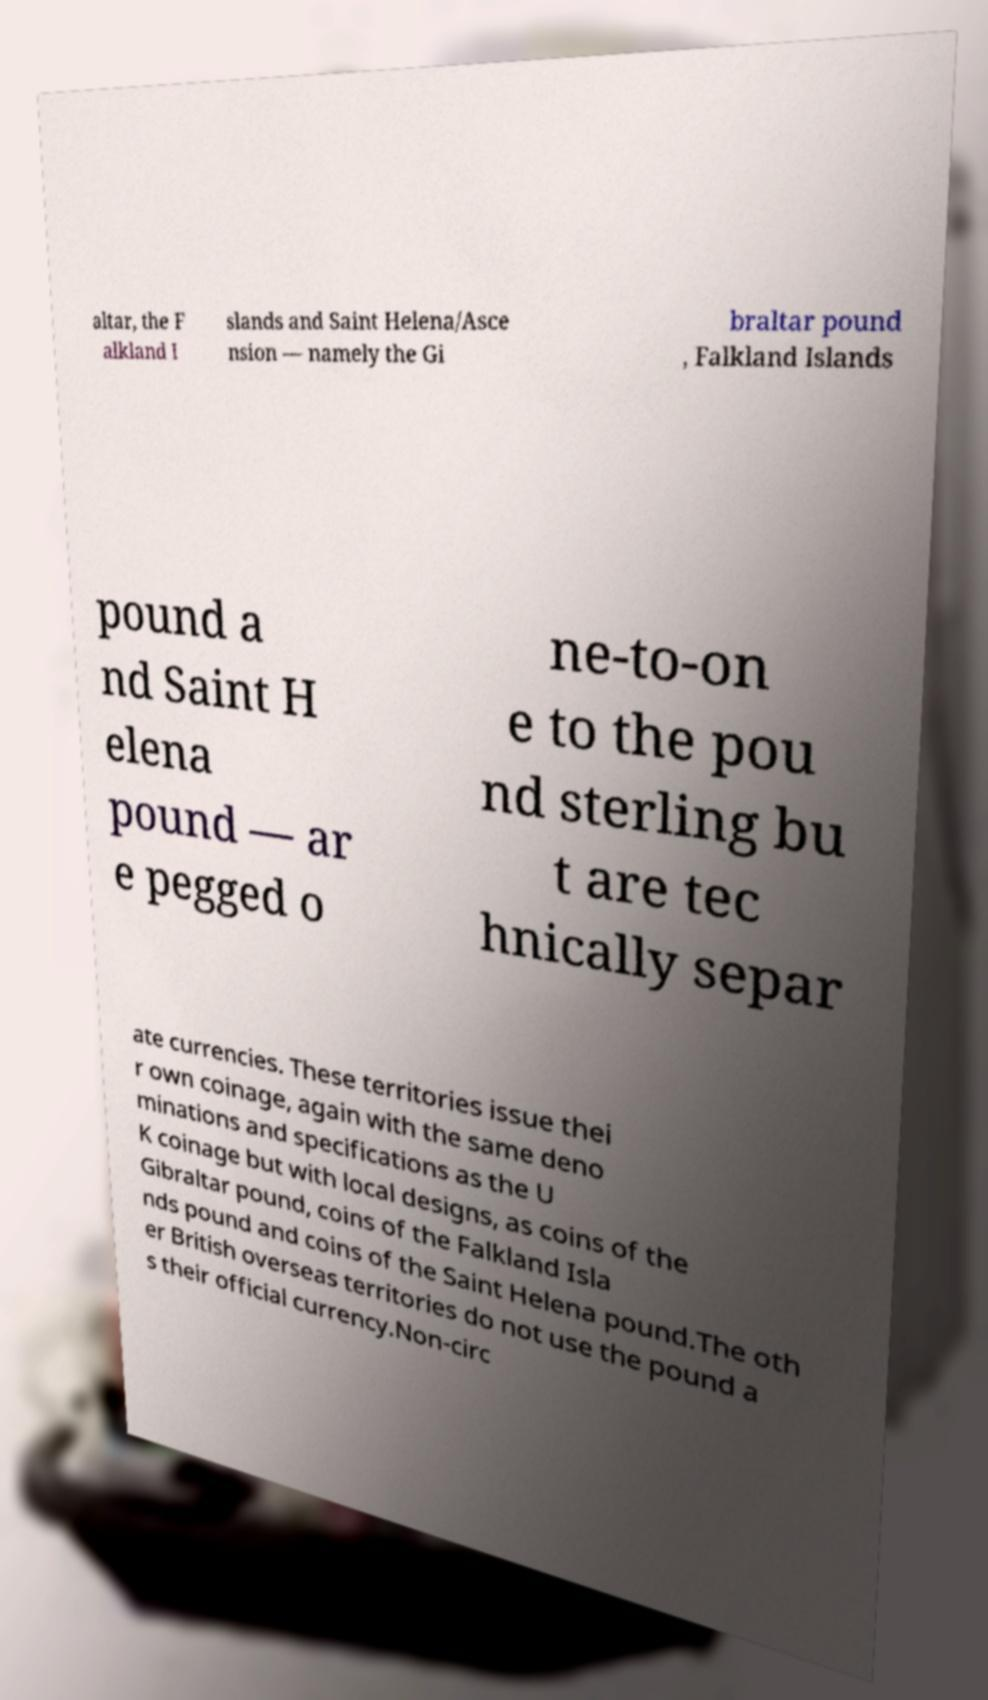I need the written content from this picture converted into text. Can you do that? altar, the F alkland I slands and Saint Helena/Asce nsion — namely the Gi braltar pound , Falkland Islands pound a nd Saint H elena pound — ar e pegged o ne-to-on e to the pou nd sterling bu t are tec hnically separ ate currencies. These territories issue thei r own coinage, again with the same deno minations and specifications as the U K coinage but with local designs, as coins of the Gibraltar pound, coins of the Falkland Isla nds pound and coins of the Saint Helena pound.The oth er British overseas territories do not use the pound a s their official currency.Non-circ 